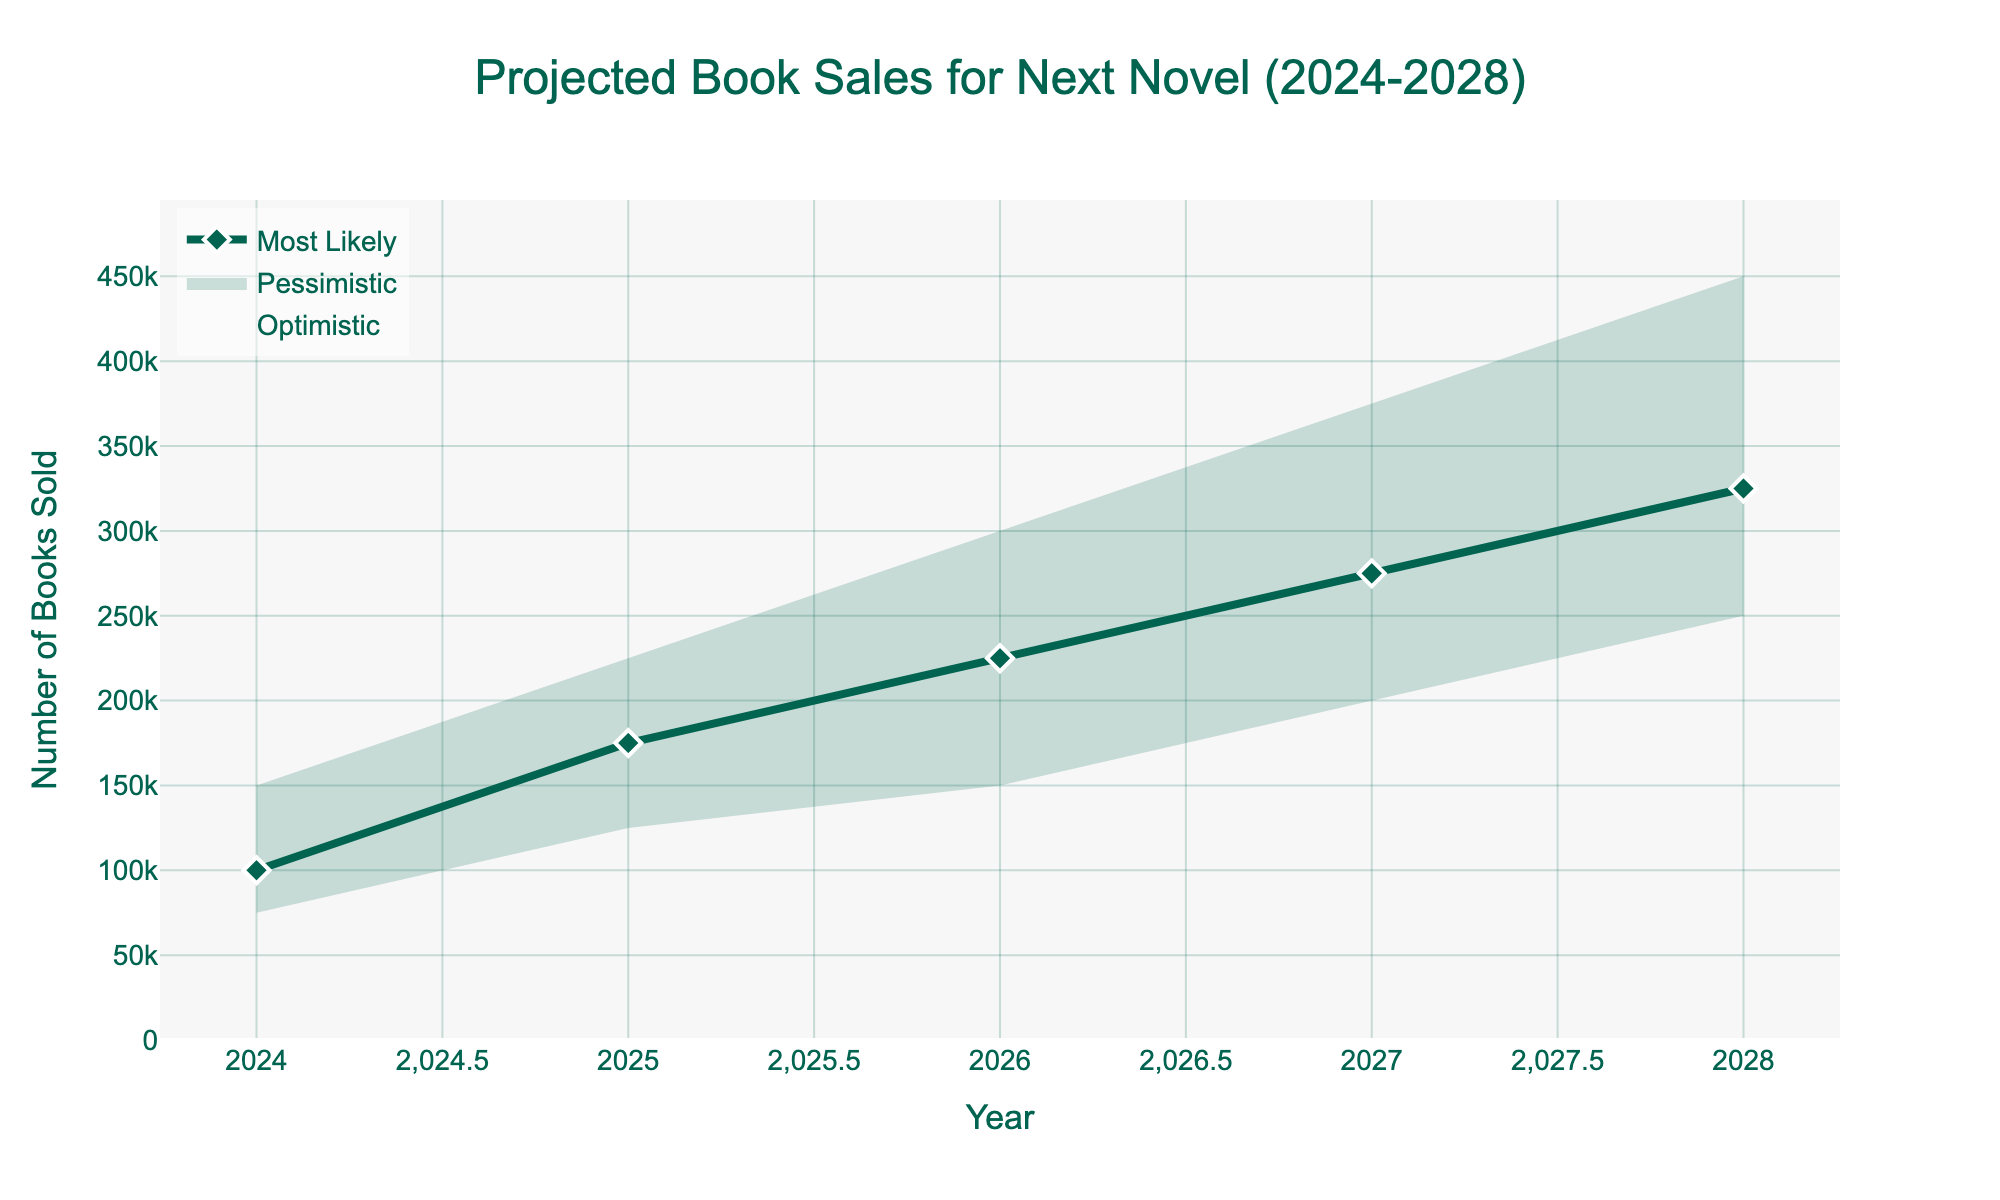what is the title of the chart? The title of the chart is usually located at the top center of the figure. It represents the summary of what the chart is about. In this case, it is displayed prominently at the top.
Answer: Projected Book Sales for Next Novel (2024-2028) What is the optimistic scenario value for 2025? To find the optimistic scenario for 2025, locate the year 2025 on the x-axis, then find the value associated with the optimistic line, typically indicated by its color and position.
Answer: 225,000 By how much are the most likely sales projected to increase from 2024 to 2026? Identify the most likely sales for 2024 and 2026. Subtract the 2024 value from the 2026 value to get the increase. The most likely values for 2024 and 2026 are 100,000 and 225,000 respectively. So, 225,000 - 100,000 = 125,000.
Answer: 125,000 What is the difference between the pessimistic scenario in 2027 and the optimistic scenario in the same year? Locate the year 2027 on the x-axis, then find the values for both the optimistic and pessimistic scenarios for that year. Subtract the pessimistic value from the optimistic value. The values are 375,000 (optimistic) and 200,000 (pessimistic), so 375,000 - 200,000 = 175,000.
Answer: 175,000 Which year shows the smallest gap between the optimistic and pessimistic scenarios? To determine the smallest gap, subtract the pessimistic value from the optimistic value for each year, then compare the differences across years. For each year: 2024 (150,000 - 75,000 = 75,000), 2025 (225,000 - 125,000 = 100,000), 2026 (300,000 - 150,000 = 150,000), 2027 (375,000 - 200,000 = 175,000), 2028 (450,000 - 250,000 = 200,000). The smallest gap is 75,000 in 2024.
Answer: 2024 How does the projected number of books sold in 2028 (most likely scenario) compare with the 2024 projection in the pessimistic scenario? Find the values for the most likely scenario in 2028 and the pessimistic scenario in 2024, then compare them. The values are 325,000 (most likely for 2028) and 75,000 (pessimistic for 2024), respectively. The 2028 most likely value is higher by 250,000.
Answer: The 2028 most likely value is higher by 250,000 What is the average projected sales for the most likely scenario from 2024 to 2028? Add the most likely scenario values for each year and then divide by the number of years (5). The values are 100,000, 175,000, 225,000, 275,000, and 325,000 respectively. Sum = 1,100,000. Average = 1,100,000 / 5.
Answer: 220,000 What is the trend observed in the pessimistic scenario over the years? Observe the line representing the pessimistic scenario from 2024 to 2028. Note that it starts at 75,000 in 2024 and gradually increases each year. The values clearly show an increasing trend.
Answer: Increasing trend 